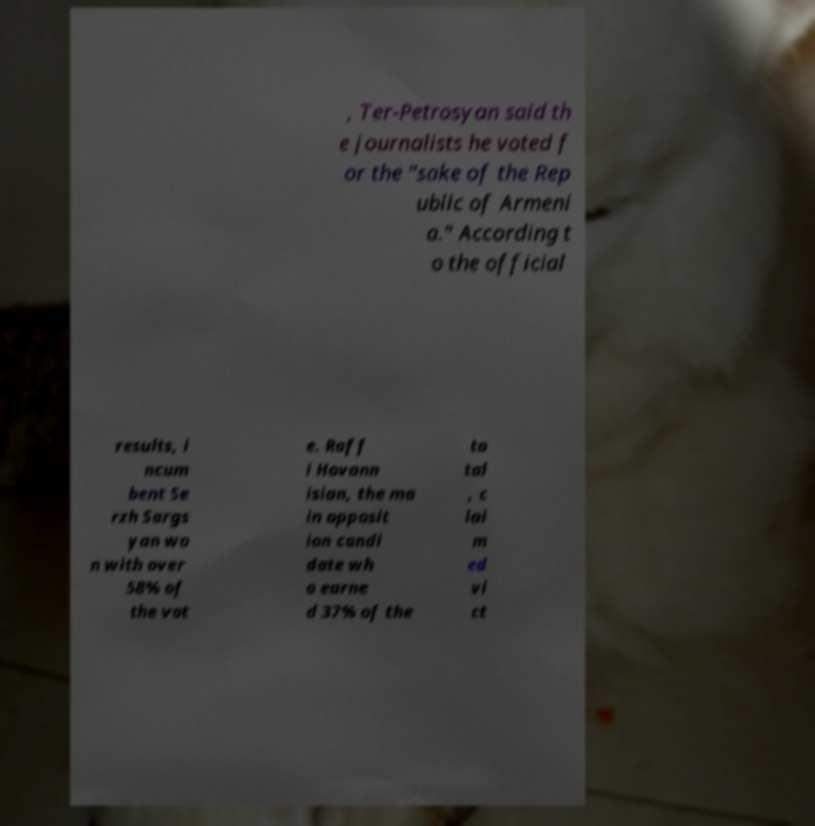Can you accurately transcribe the text from the provided image for me? , Ter-Petrosyan said th e journalists he voted f or the "sake of the Rep ublic of Armeni a." According t o the official results, i ncum bent Se rzh Sargs yan wo n with over 58% of the vot e. Raff i Hovann isian, the ma in opposit ion candi date wh o earne d 37% of the to tal , c lai m ed vi ct 